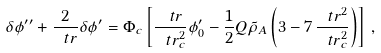<formula> <loc_0><loc_0><loc_500><loc_500>\delta \phi ^ { \prime \prime } + \frac { 2 } { \ t r } \delta \phi ^ { \prime } = \Phi _ { c } \left [ \frac { \ t r } { \ t r _ { c } ^ { 2 } } \phi _ { 0 } ^ { \prime } - \frac { 1 } { 2 } Q \tilde { \rho } _ { A } \left ( 3 - 7 \, \frac { \ t r ^ { 2 } } { \ t r _ { c } ^ { 2 } } \right ) \right ] \, ,</formula> 